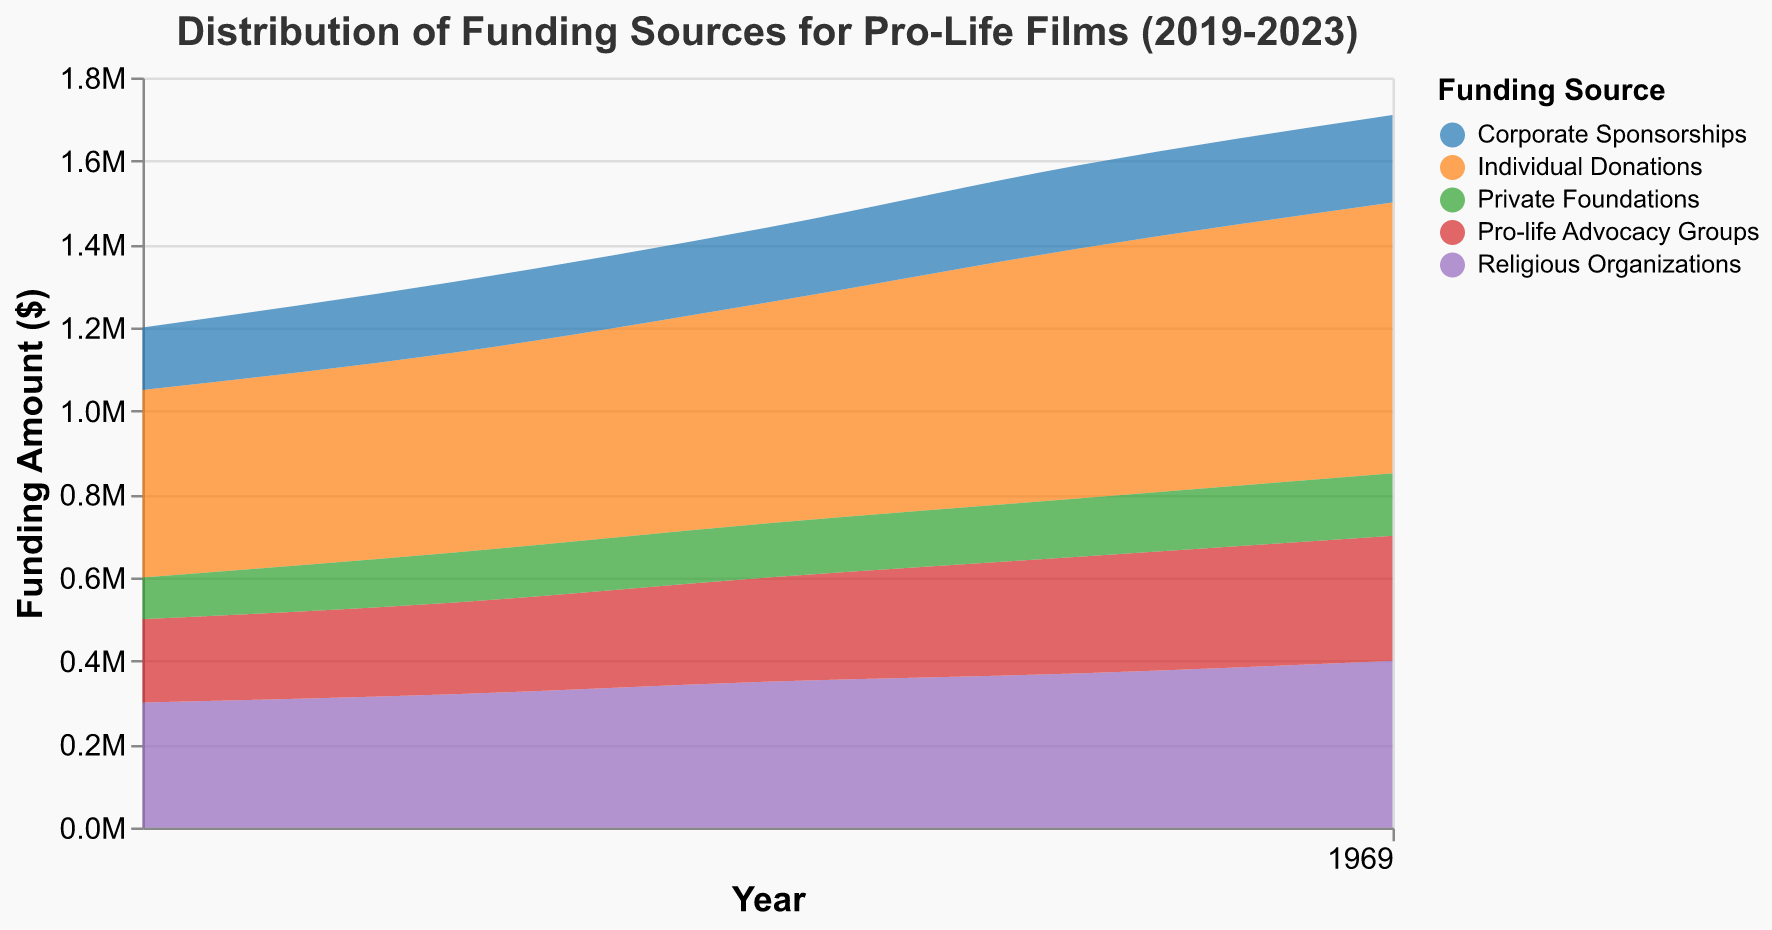What is the title of the figure? The title of a figure is usually located at the top of the chart, central and in a slightly larger font. Here, it reads "Distribution of Funding Sources for Pro-Life Films (2019-2023)".
Answer: Distribution of Funding Sources for Pro-Life Films (2019-2023) Which funding source contributed the most in 2023? To determine the funding source with the highest contribution in 2023, look at the chart's x-axis for 2023 and compare the heights of the bands. "Individual Donations" is the tallest, indicating the highest contribution.
Answer: Individual Donations How did the amount of funding from Religious Organizations change from 2019 to 2023? Examine the chart for the amount allocated to "Religious Organizations" across the years 2019 to 2023. Observe the height of the bands for each year. The amount increased from 300,000 in 2019 to 400,000 in 2023.
Answer: Increased by 100,000 Which funding source shows a steady increase over the 5 years? To identify the funding source with a steady increase, look for bands that show a consistent upward trend from 2019 to 2023. Both "Individual Donations" and "Religious Organizations" demonstrate a steady increase.
Answer: Individual Donations and Religious Organizations What is the total amount of funding for the year 2020? Sum the contributions of all funding sources for 2020. The amounts are: 480,000 (Individual Donations) + 320,000 (Religious Organizations) + 220,000 (Pro-life Advocacy Groups) + 170,000 (Corporate Sponsorships) + 120,000 (Private Foundations).
Answer: 1,310,000 Which funding source had the least contribution in 2021? Find the shortest band in 2021. The data bands for 2021 show "Private Foundations" as the lowest, indicating the least contribution of 130,000.
Answer: Private Foundations By how much did the funding from Pro-life Advocacy Groups increase from 2020 to 2022? Calculate the difference between the amounts in 2020 and 2022 for "Pro-life Advocacy Groups". The funding increased from 220,000 in 2020 to 280,000 in 2022.
Answer: Increased by 60,000 Compare the funding amounts of Individual Donations and Corporate Sponsorships in 2023. Which is higher and by how much? Identify the amounts for "Individual Donations" and "Corporate Sponsorships" in 2023. They are 650,000 and 210,000 respectively. Therefore, Individual Donations are higher by 440,000.
Answer: Individual Donations by 440,000 